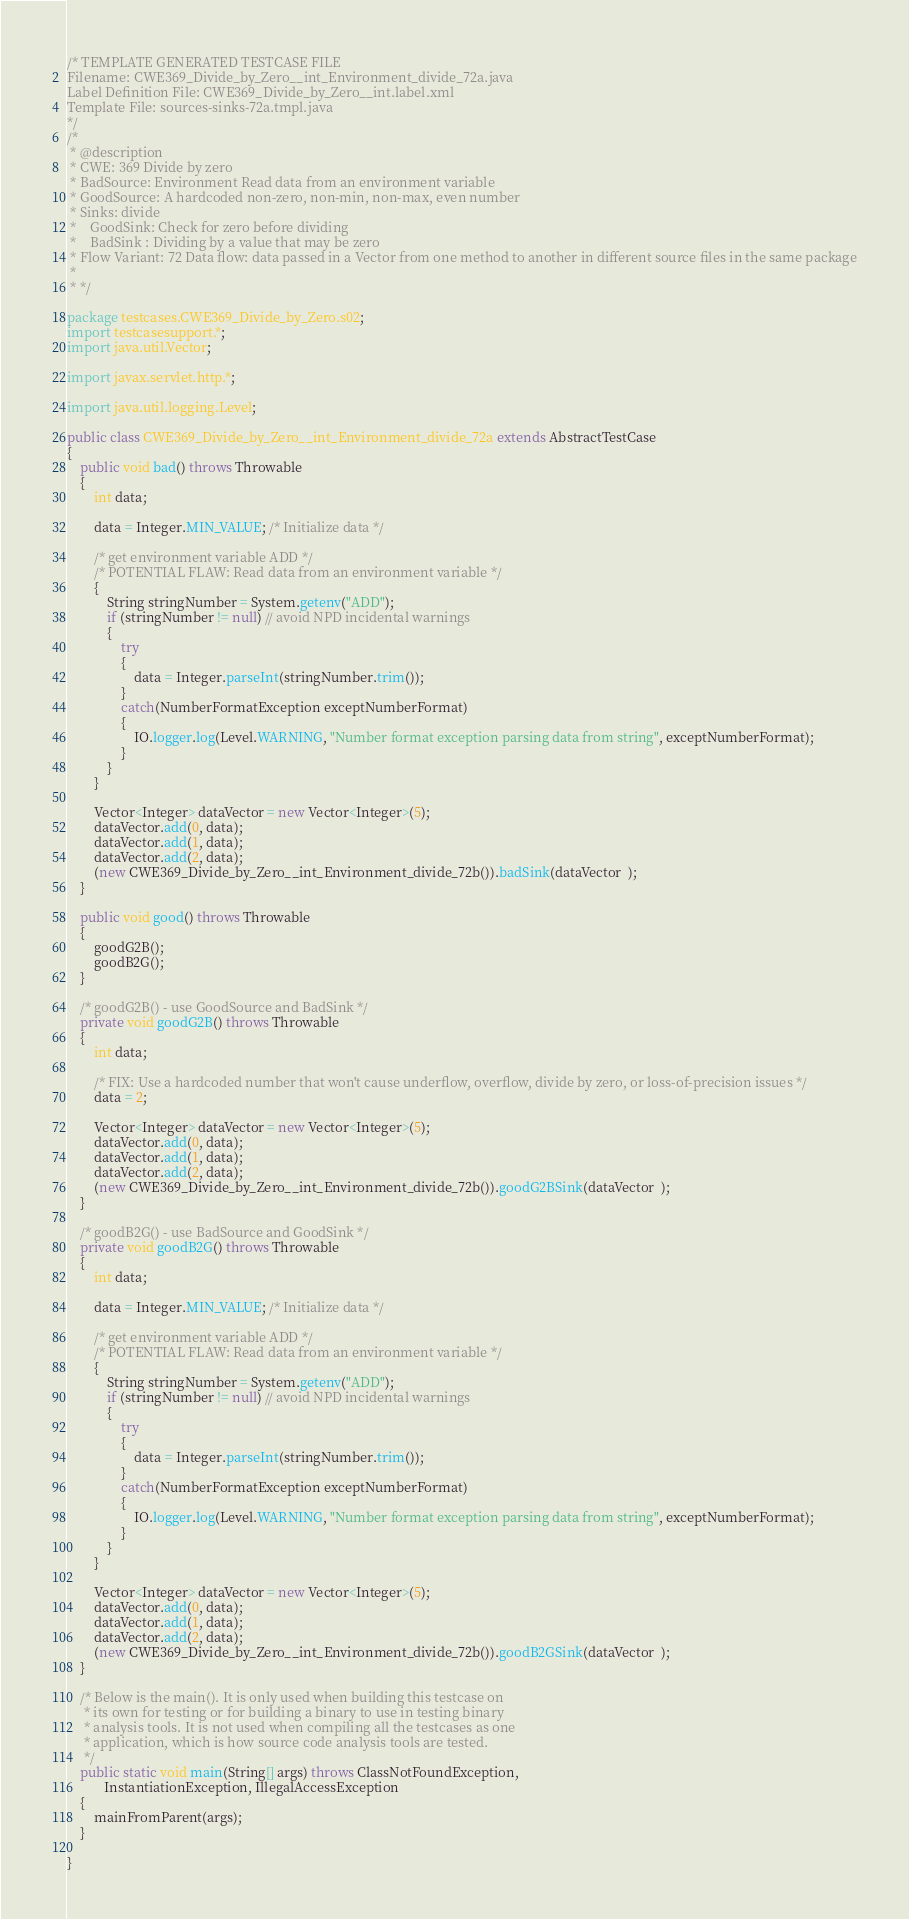<code> <loc_0><loc_0><loc_500><loc_500><_Java_>/* TEMPLATE GENERATED TESTCASE FILE
Filename: CWE369_Divide_by_Zero__int_Environment_divide_72a.java
Label Definition File: CWE369_Divide_by_Zero__int.label.xml
Template File: sources-sinks-72a.tmpl.java
*/
/*
 * @description
 * CWE: 369 Divide by zero
 * BadSource: Environment Read data from an environment variable
 * GoodSource: A hardcoded non-zero, non-min, non-max, even number
 * Sinks: divide
 *    GoodSink: Check for zero before dividing
 *    BadSink : Dividing by a value that may be zero
 * Flow Variant: 72 Data flow: data passed in a Vector from one method to another in different source files in the same package
 *
 * */

package testcases.CWE369_Divide_by_Zero.s02;
import testcasesupport.*;
import java.util.Vector;

import javax.servlet.http.*;

import java.util.logging.Level;

public class CWE369_Divide_by_Zero__int_Environment_divide_72a extends AbstractTestCase
{
    public void bad() throws Throwable
    {
        int data;

        data = Integer.MIN_VALUE; /* Initialize data */

        /* get environment variable ADD */
        /* POTENTIAL FLAW: Read data from an environment variable */
        {
            String stringNumber = System.getenv("ADD");
            if (stringNumber != null) // avoid NPD incidental warnings
            {
                try
                {
                    data = Integer.parseInt(stringNumber.trim());
                }
                catch(NumberFormatException exceptNumberFormat)
                {
                    IO.logger.log(Level.WARNING, "Number format exception parsing data from string", exceptNumberFormat);
                }
            }
        }

        Vector<Integer> dataVector = new Vector<Integer>(5);
        dataVector.add(0, data);
        dataVector.add(1, data);
        dataVector.add(2, data);
        (new CWE369_Divide_by_Zero__int_Environment_divide_72b()).badSink(dataVector  );
    }

    public void good() throws Throwable
    {
        goodG2B();
        goodB2G();
    }

    /* goodG2B() - use GoodSource and BadSink */
    private void goodG2B() throws Throwable
    {
        int data;

        /* FIX: Use a hardcoded number that won't cause underflow, overflow, divide by zero, or loss-of-precision issues */
        data = 2;

        Vector<Integer> dataVector = new Vector<Integer>(5);
        dataVector.add(0, data);
        dataVector.add(1, data);
        dataVector.add(2, data);
        (new CWE369_Divide_by_Zero__int_Environment_divide_72b()).goodG2BSink(dataVector  );
    }

    /* goodB2G() - use BadSource and GoodSink */
    private void goodB2G() throws Throwable
    {
        int data;

        data = Integer.MIN_VALUE; /* Initialize data */

        /* get environment variable ADD */
        /* POTENTIAL FLAW: Read data from an environment variable */
        {
            String stringNumber = System.getenv("ADD");
            if (stringNumber != null) // avoid NPD incidental warnings
            {
                try
                {
                    data = Integer.parseInt(stringNumber.trim());
                }
                catch(NumberFormatException exceptNumberFormat)
                {
                    IO.logger.log(Level.WARNING, "Number format exception parsing data from string", exceptNumberFormat);
                }
            }
        }

        Vector<Integer> dataVector = new Vector<Integer>(5);
        dataVector.add(0, data);
        dataVector.add(1, data);
        dataVector.add(2, data);
        (new CWE369_Divide_by_Zero__int_Environment_divide_72b()).goodB2GSink(dataVector  );
    }

    /* Below is the main(). It is only used when building this testcase on
     * its own for testing or for building a binary to use in testing binary
     * analysis tools. It is not used when compiling all the testcases as one
     * application, which is how source code analysis tools are tested.
     */
    public static void main(String[] args) throws ClassNotFoundException,
           InstantiationException, IllegalAccessException
    {
        mainFromParent(args);
    }

}
</code> 